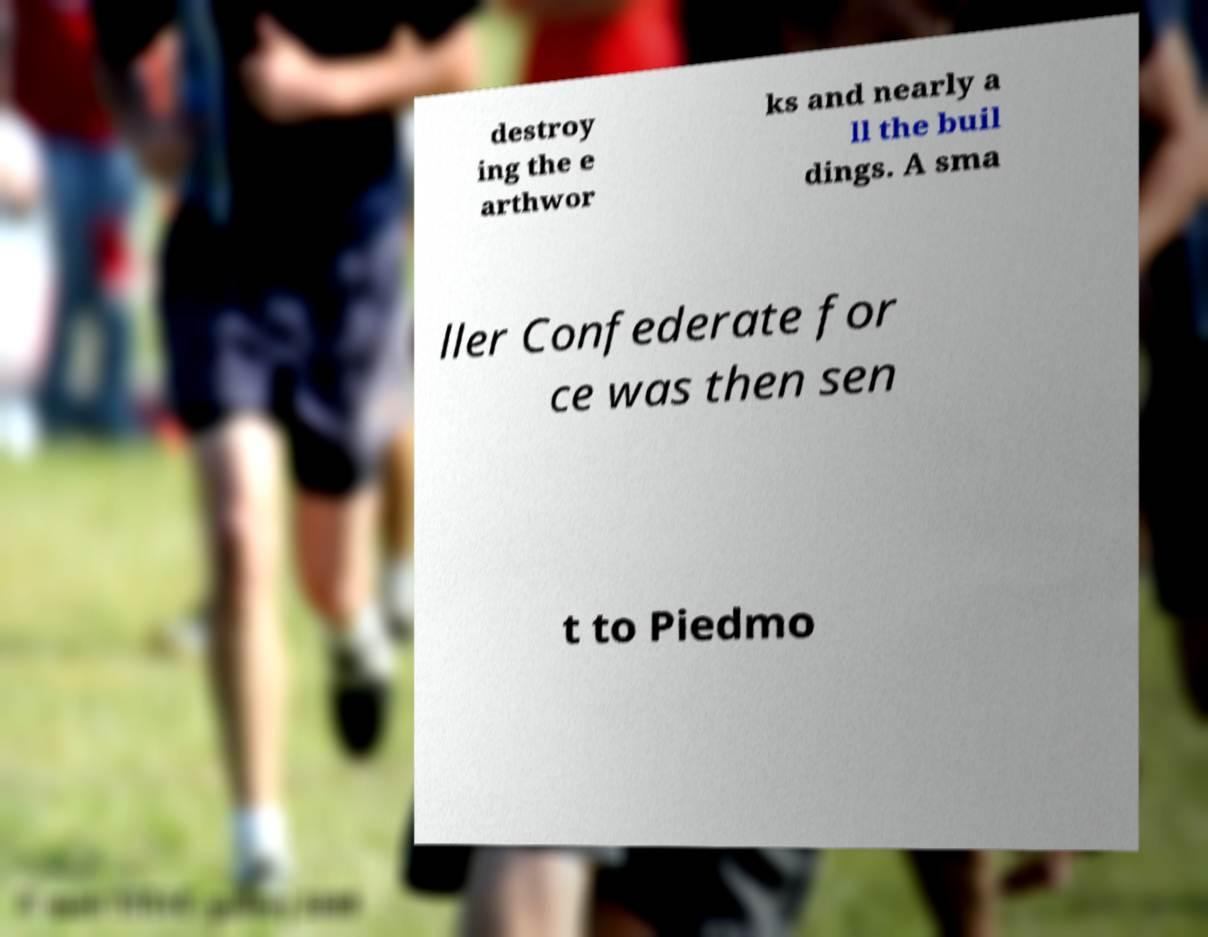Can you read and provide the text displayed in the image?This photo seems to have some interesting text. Can you extract and type it out for me? destroy ing the e arthwor ks and nearly a ll the buil dings. A sma ller Confederate for ce was then sen t to Piedmo 